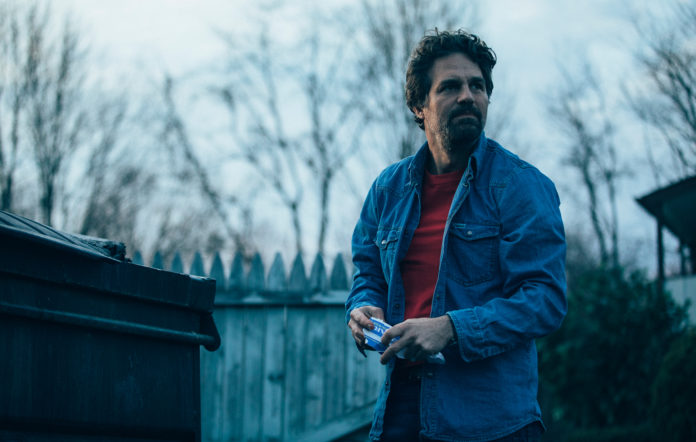What's the mood of this scene? The mood of the scene is quite tense and somewhat mysterious. The man's serious expression and the subdued light suggest that something significant or concerning is happening. The rustic background with leafless trees adds to a feeling of desolation or anticipation. Create a detailed narrative exploring the reasons for his serious expression. James had been receiving anonymous texts for weeks, each one more cryptic than the last. Tonight, the message was clear: a meet-up at the old dumpster behind the fence. As he walked down the desolate path, memories of his late brother flooded back. Could it be him? The messages hinted at knowing things only his brother would. His hand trembled slightly as he clutched his phone, which displayed the final text: 'Tell no one. Come alone.' Arriving at the meeting point, he scanned the area—nothing, but an eerie silence. His silhouette cast a long shadow across the fence, making him appear even more solitary and apprehensive. As he waited, the seconds felt like hours, his mind a whirlwind of questions and fears. The rustling of leaves pulled his attention, and he turned sharply, ready to confront whatever secrets this night held. 